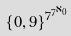<formula> <loc_0><loc_0><loc_500><loc_500>\{ 0 , 9 \} ^ { 7 ^ { 7 ^ { \aleph _ { 0 } } } }</formula> 